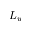<formula> <loc_0><loc_0><loc_500><loc_500>L _ { w }</formula> 